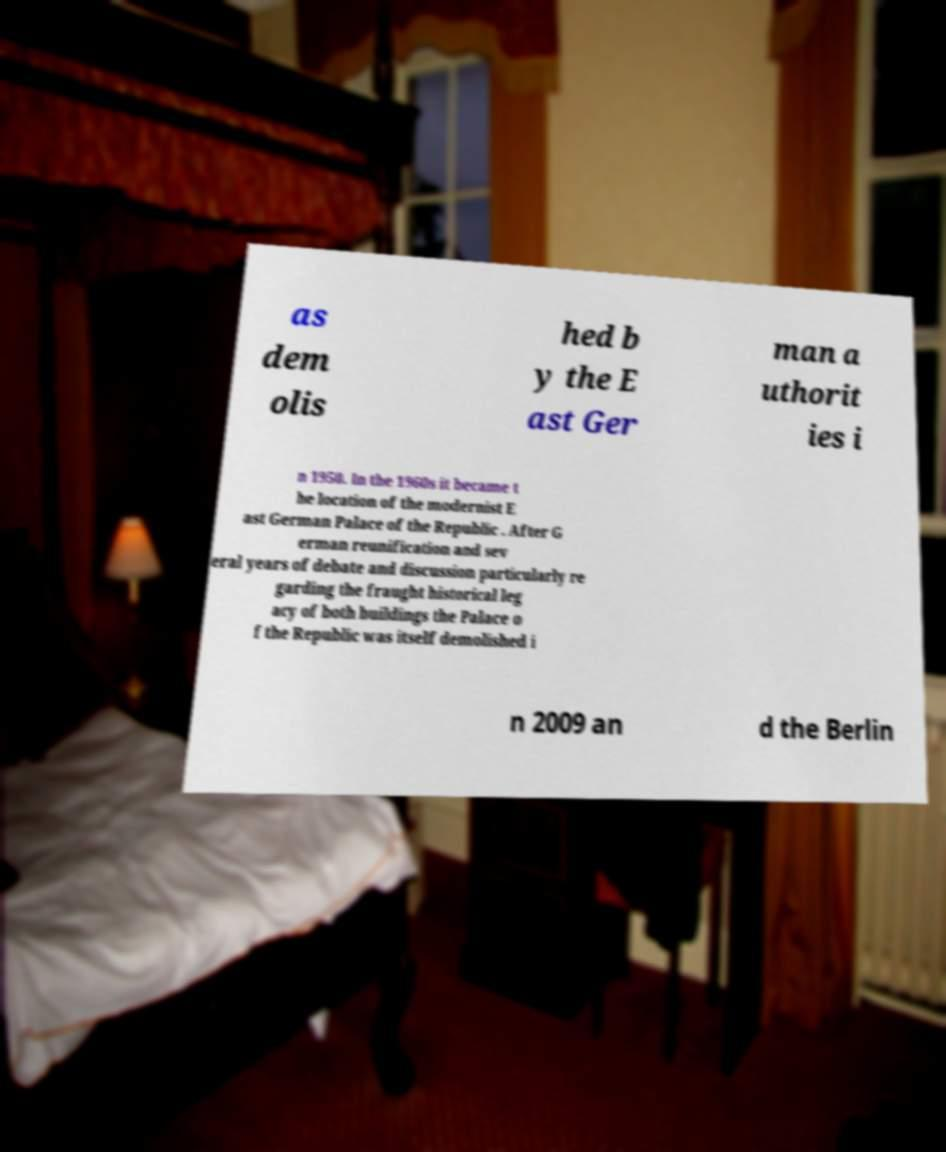Please read and relay the text visible in this image. What does it say? as dem olis hed b y the E ast Ger man a uthorit ies i n 1950. In the 1960s it became t he location of the modernist E ast German Palace of the Republic . After G erman reunification and sev eral years of debate and discussion particularly re garding the fraught historical leg acy of both buildings the Palace o f the Republic was itself demolished i n 2009 an d the Berlin 